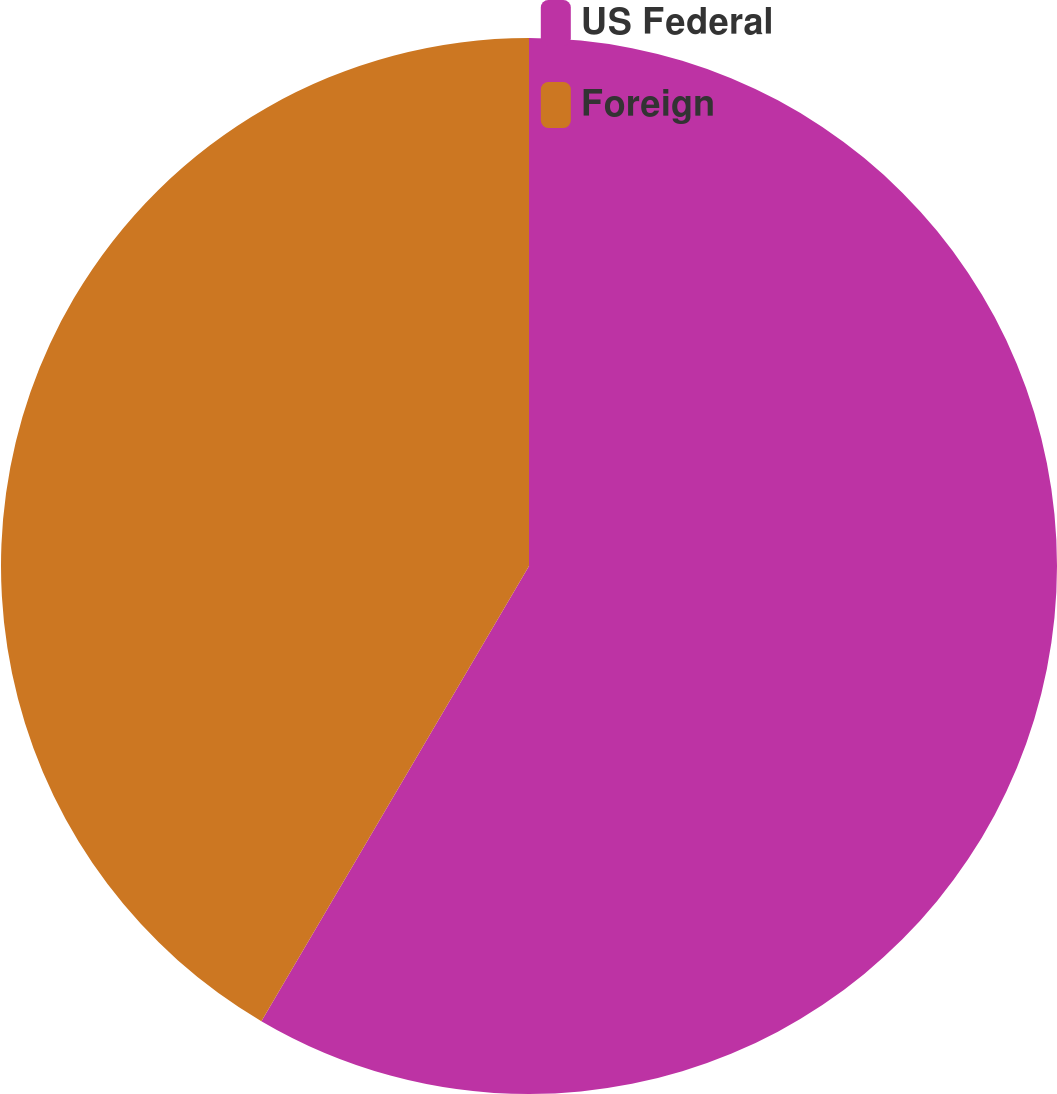<chart> <loc_0><loc_0><loc_500><loc_500><pie_chart><fcel>US Federal<fcel>Foreign<nl><fcel>58.46%<fcel>41.54%<nl></chart> 